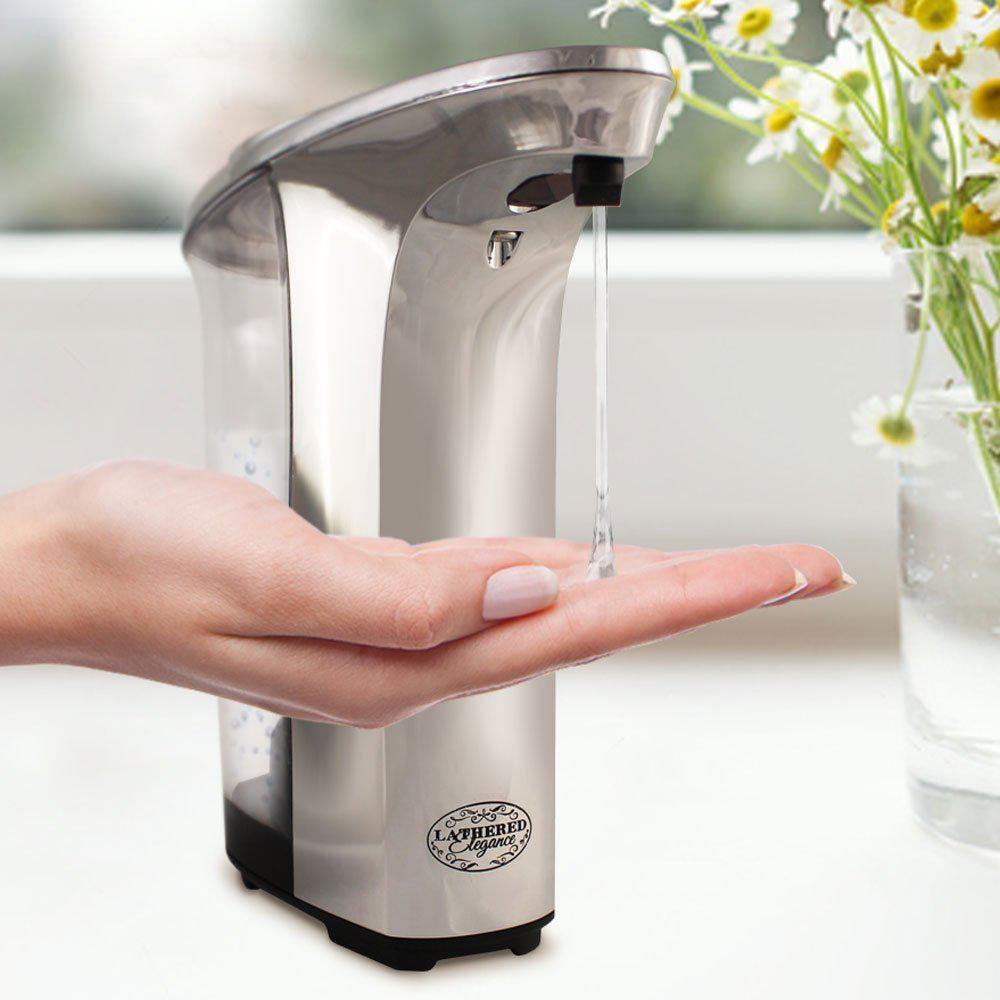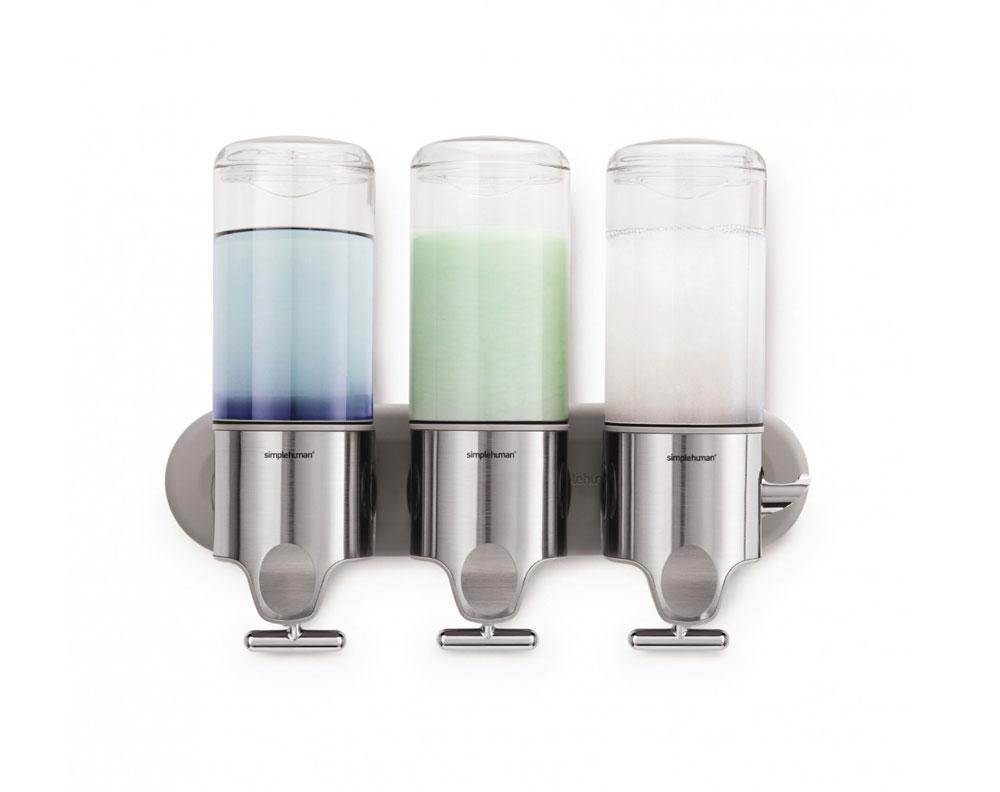The first image is the image on the left, the second image is the image on the right. Assess this claim about the two images: "In one image soap is coming out of the dispenser.". Correct or not? Answer yes or no. Yes. The first image is the image on the left, the second image is the image on the right. For the images shown, is this caption "An image contains a human hand obtaining soap from a dispenser." true? Answer yes or no. Yes. 